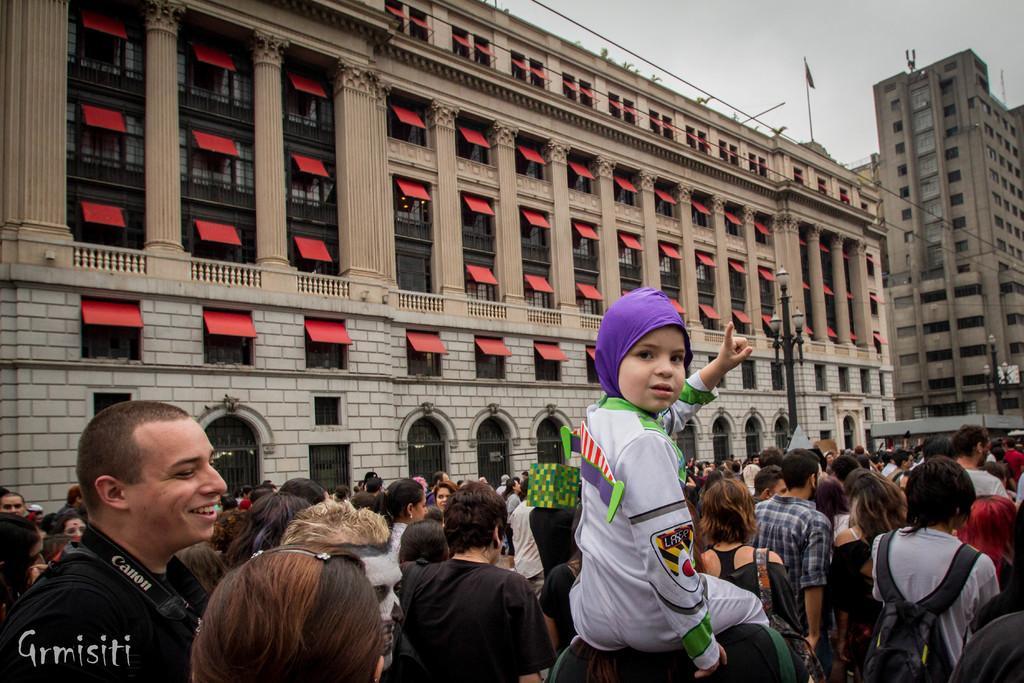How would you summarize this image in a sentence or two? This picture describes about group of people, few people wore backpacks, in the background we can see few poles and lights, and also we can find few buildings. 